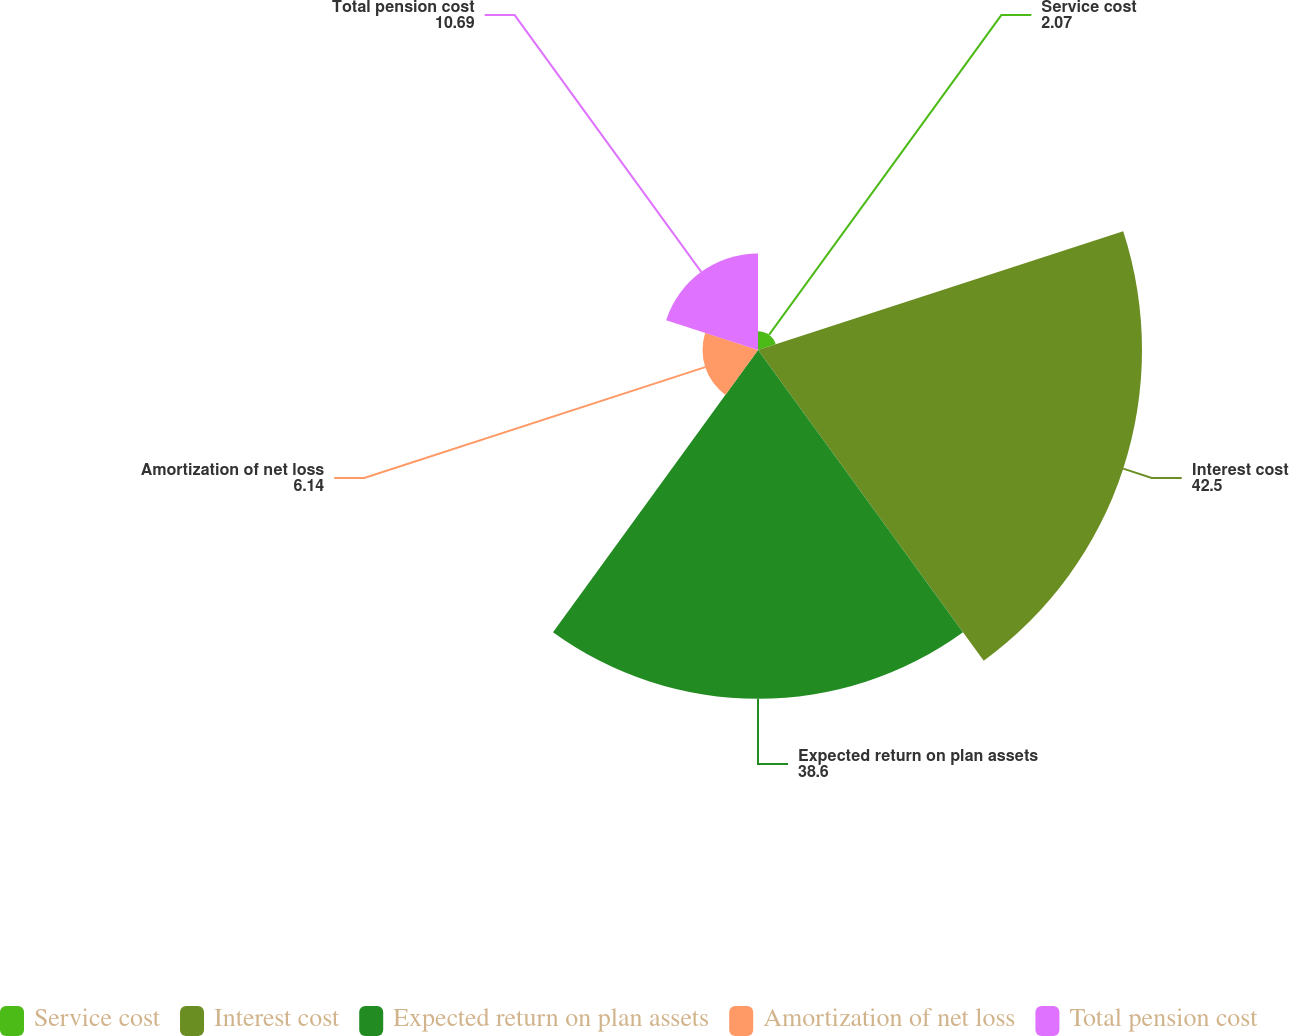<chart> <loc_0><loc_0><loc_500><loc_500><pie_chart><fcel>Service cost<fcel>Interest cost<fcel>Expected return on plan assets<fcel>Amortization of net loss<fcel>Total pension cost<nl><fcel>2.07%<fcel>42.5%<fcel>38.6%<fcel>6.14%<fcel>10.69%<nl></chart> 